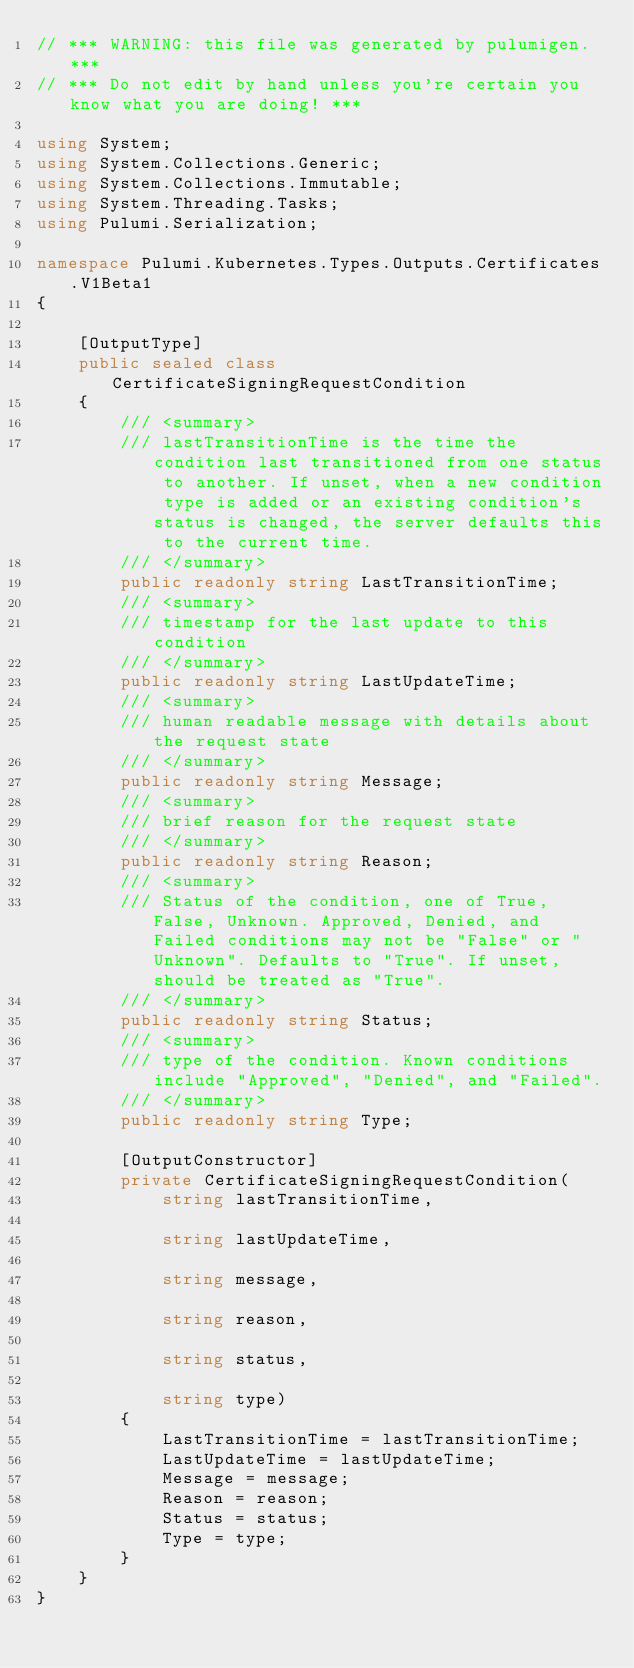<code> <loc_0><loc_0><loc_500><loc_500><_C#_>// *** WARNING: this file was generated by pulumigen. ***
// *** Do not edit by hand unless you're certain you know what you are doing! ***

using System;
using System.Collections.Generic;
using System.Collections.Immutable;
using System.Threading.Tasks;
using Pulumi.Serialization;

namespace Pulumi.Kubernetes.Types.Outputs.Certificates.V1Beta1
{

    [OutputType]
    public sealed class CertificateSigningRequestCondition
    {
        /// <summary>
        /// lastTransitionTime is the time the condition last transitioned from one status to another. If unset, when a new condition type is added or an existing condition's status is changed, the server defaults this to the current time.
        /// </summary>
        public readonly string LastTransitionTime;
        /// <summary>
        /// timestamp for the last update to this condition
        /// </summary>
        public readonly string LastUpdateTime;
        /// <summary>
        /// human readable message with details about the request state
        /// </summary>
        public readonly string Message;
        /// <summary>
        /// brief reason for the request state
        /// </summary>
        public readonly string Reason;
        /// <summary>
        /// Status of the condition, one of True, False, Unknown. Approved, Denied, and Failed conditions may not be "False" or "Unknown". Defaults to "True". If unset, should be treated as "True".
        /// </summary>
        public readonly string Status;
        /// <summary>
        /// type of the condition. Known conditions include "Approved", "Denied", and "Failed".
        /// </summary>
        public readonly string Type;

        [OutputConstructor]
        private CertificateSigningRequestCondition(
            string lastTransitionTime,

            string lastUpdateTime,

            string message,

            string reason,

            string status,

            string type)
        {
            LastTransitionTime = lastTransitionTime;
            LastUpdateTime = lastUpdateTime;
            Message = message;
            Reason = reason;
            Status = status;
            Type = type;
        }
    }
}
</code> 